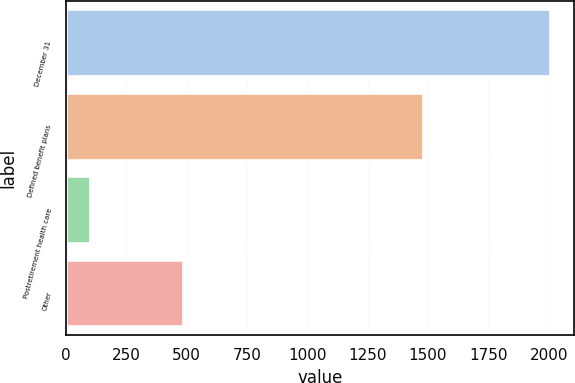Convert chart to OTSL. <chart><loc_0><loc_0><loc_500><loc_500><bar_chart><fcel>December 31<fcel>Defined benefit plans<fcel>Postretirement health care<fcel>Other<nl><fcel>2004<fcel>1481<fcel>100<fcel>486<nl></chart> 